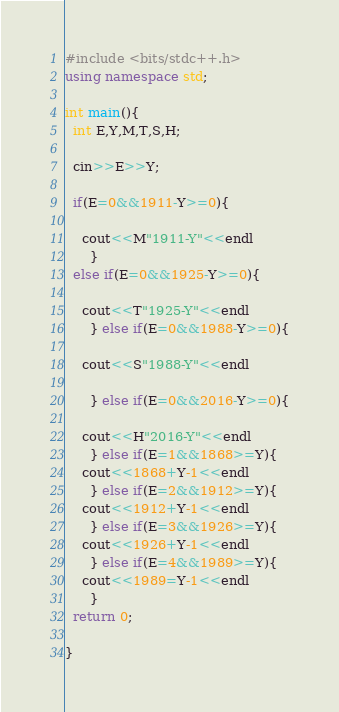Convert code to text. <code><loc_0><loc_0><loc_500><loc_500><_C++_>#include <bits/stdc++.h>
using namespace std;

int main(){
  int E,Y,M,T,S,H;

  cin>>E>>Y;

  if(E=0&&1911-Y>=0){
    
    cout<<M"1911-Y"<<endl
      }
  else if(E=0&&1925-Y>=0){

    cout<<T"1925-Y"<<endl
      } else if(E=0&&1988-Y>=0){

    cout<<S"1988-Y"<<endl
  
      } else if(E=0&&2016-Y>=0){

    cout<<H"2016-Y"<<endl
      } else if(E=1&&1868>=Y){
    cout<<1868+Y-1<<endl
      } else if(E=2&&1912>=Y){
    cout<<1912+Y-1<<endl
      } else if(E=3&&1926>=Y){
    cout<<1926+Y-1<<endl
      } else if(E=4&&1989>=Y){
    cout<<1989=Y-1<<endl
      }
  return 0;

}

</code> 